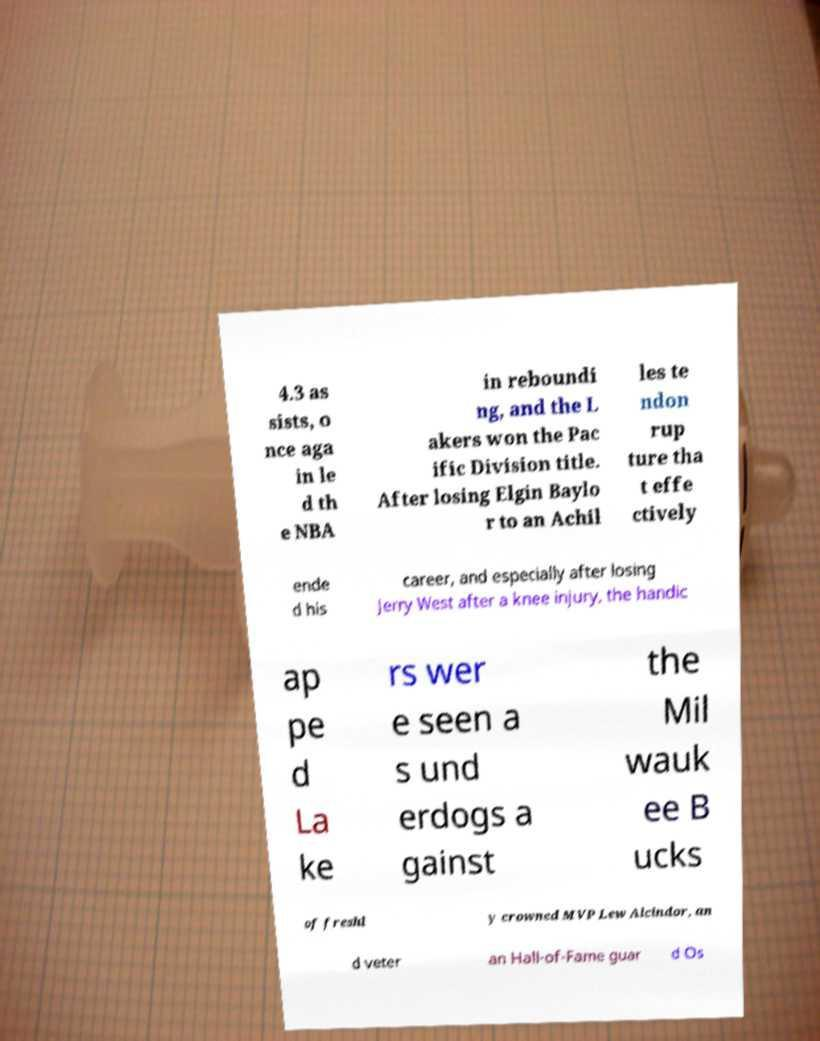Can you accurately transcribe the text from the provided image for me? 4.3 as sists, o nce aga in le d th e NBA in reboundi ng, and the L akers won the Pac ific Division title. After losing Elgin Baylo r to an Achil les te ndon rup ture tha t effe ctively ende d his career, and especially after losing Jerry West after a knee injury, the handic ap pe d La ke rs wer e seen a s und erdogs a gainst the Mil wauk ee B ucks of freshl y crowned MVP Lew Alcindor, an d veter an Hall-of-Fame guar d Os 